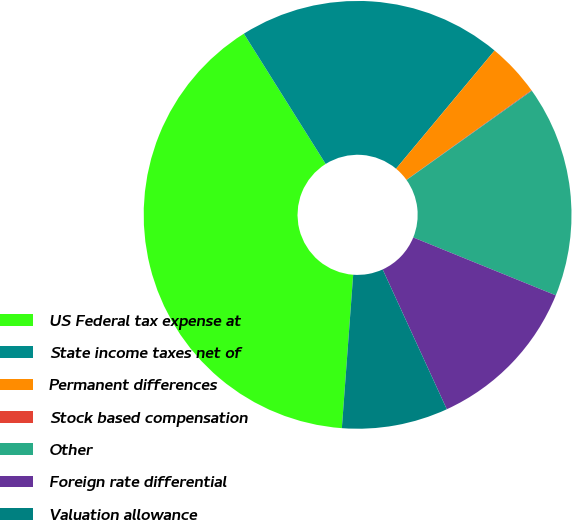Convert chart. <chart><loc_0><loc_0><loc_500><loc_500><pie_chart><fcel>US Federal tax expense at<fcel>State income taxes net of<fcel>Permanent differences<fcel>Stock based compensation<fcel>Other<fcel>Foreign rate differential<fcel>Valuation allowance<nl><fcel>39.9%<fcel>19.98%<fcel>4.04%<fcel>0.05%<fcel>15.99%<fcel>12.01%<fcel>8.02%<nl></chart> 